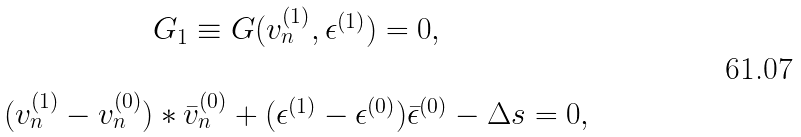Convert formula to latex. <formula><loc_0><loc_0><loc_500><loc_500>\begin{array} { c } G _ { 1 } \equiv G ( { v _ { n } ^ { ( 1 ) } } , \epsilon ^ { ( 1 ) } ) = 0 , \\ \\ ( { v _ { n } ^ { ( 1 ) } } - { v _ { n } ^ { ( 0 ) } } ) * { \bar { v } } _ { n } ^ { ( 0 ) } + ( \epsilon ^ { ( 1 ) } - \epsilon ^ { ( 0 ) } ) { \bar { \epsilon } } ^ { ( 0 ) } - \Delta s = 0 , \end{array}</formula> 